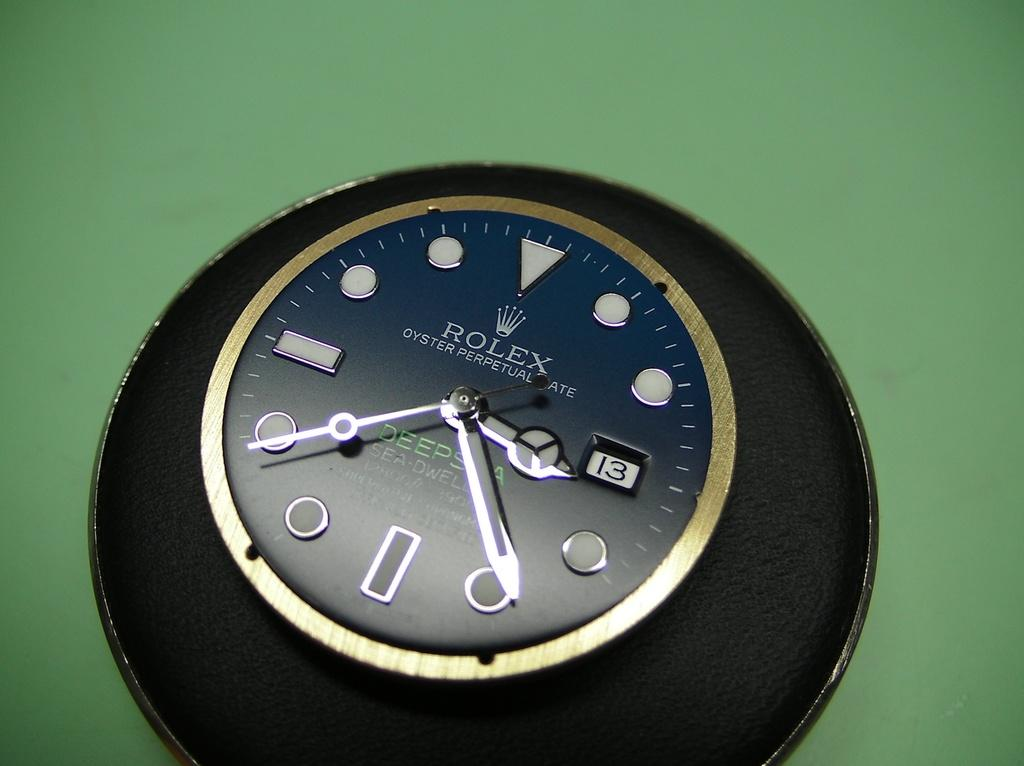<image>
Present a compact description of the photo's key features. A clock face of a Rolex sits on a black and green background. 